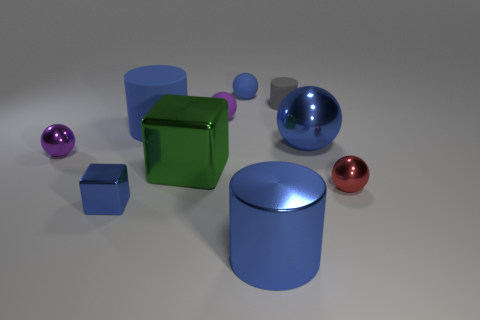Do the red metal sphere and the green metallic cube have the same size?
Your answer should be compact. No. What is the shape of the tiny thing that is the same color as the small shiny block?
Your response must be concise. Sphere. Are there more cyan objects than rubber objects?
Your answer should be very brief. No. What color is the large metal object to the left of the rubber ball that is in front of the small matte object to the right of the blue matte sphere?
Give a very brief answer. Green. There is a tiny gray matte object that is to the right of the large green shiny block; is its shape the same as the small blue metallic object?
Your response must be concise. No. What color is the matte cylinder that is the same size as the blue block?
Provide a succinct answer. Gray. What number of metal cylinders are there?
Provide a short and direct response. 1. Is the big blue cylinder that is on the right side of the big green thing made of the same material as the large block?
Offer a very short reply. Yes. What is the cylinder that is both behind the big blue ball and on the right side of the large blue rubber cylinder made of?
Keep it short and to the point. Rubber. There is a metallic ball that is the same color as the tiny metallic block; what is its size?
Offer a very short reply. Large. 